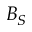<formula> <loc_0><loc_0><loc_500><loc_500>B _ { S }</formula> 